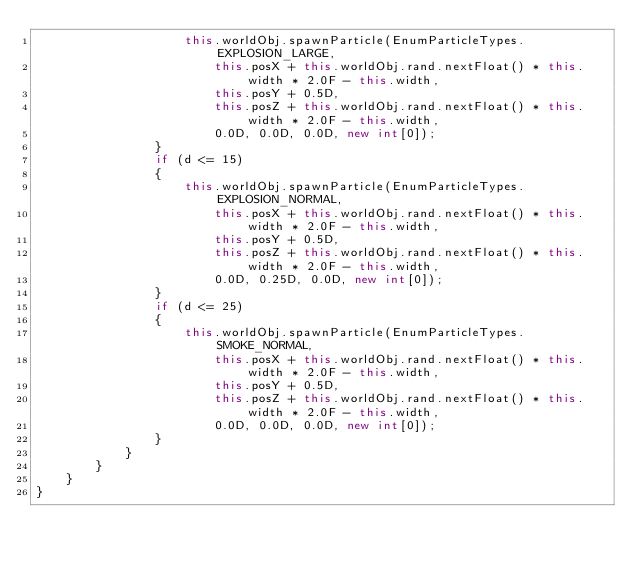Convert code to text. <code><loc_0><loc_0><loc_500><loc_500><_Java_>					this.worldObj.spawnParticle(EnumParticleTypes.EXPLOSION_LARGE, 
						this.posX + this.worldObj.rand.nextFloat() * this.width * 2.0F - this.width,
						this.posY + 0.5D,
						this.posZ + this.worldObj.rand.nextFloat() * this.width * 2.0F - this.width,
						0.0D, 0.0D, 0.0D, new int[0]);
				}
				if (d <= 15)
				{
					this.worldObj.spawnParticle(EnumParticleTypes.EXPLOSION_NORMAL, 
						this.posX + this.worldObj.rand.nextFloat() * this.width * 2.0F - this.width,
						this.posY + 0.5D,
						this.posZ + this.worldObj.rand.nextFloat() * this.width * 2.0F - this.width,
						0.0D, 0.25D, 0.0D, new int[0]);
				}
				if (d <= 25)
				{
					this.worldObj.spawnParticle(EnumParticleTypes.SMOKE_NORMAL, 
						this.posX + this.worldObj.rand.nextFloat() * this.width * 2.0F - this.width,
						this.posY + 0.5D,
						this.posZ + this.worldObj.rand.nextFloat() * this.width * 2.0F - this.width,
						0.0D, 0.0D, 0.0D, new int[0]);
				}
			}
    	}
    }
}
</code> 